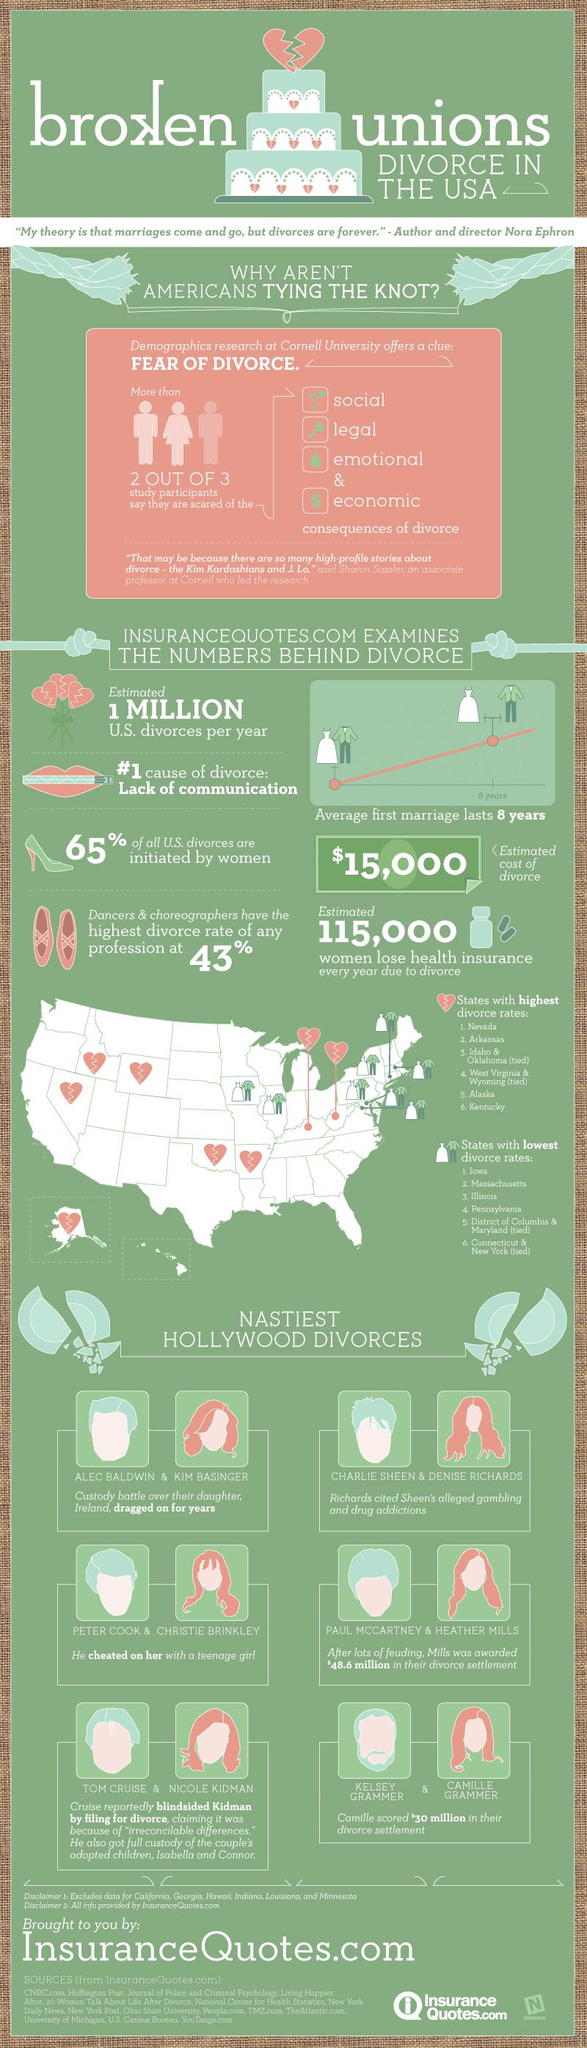Point out several critical features in this image. In the United States, 35% of all divorces were not initiated by women. The average estimated cost of divorce in the United States is approximately $15,000. The state with the second highest divorce rate in the United States is Arkansas. Divorce is a significant issue in America, and the deep root cause of this phenomenon is lack of communication between spouses. Camille Grammer was awarded $30 million in the divorce settlement. 